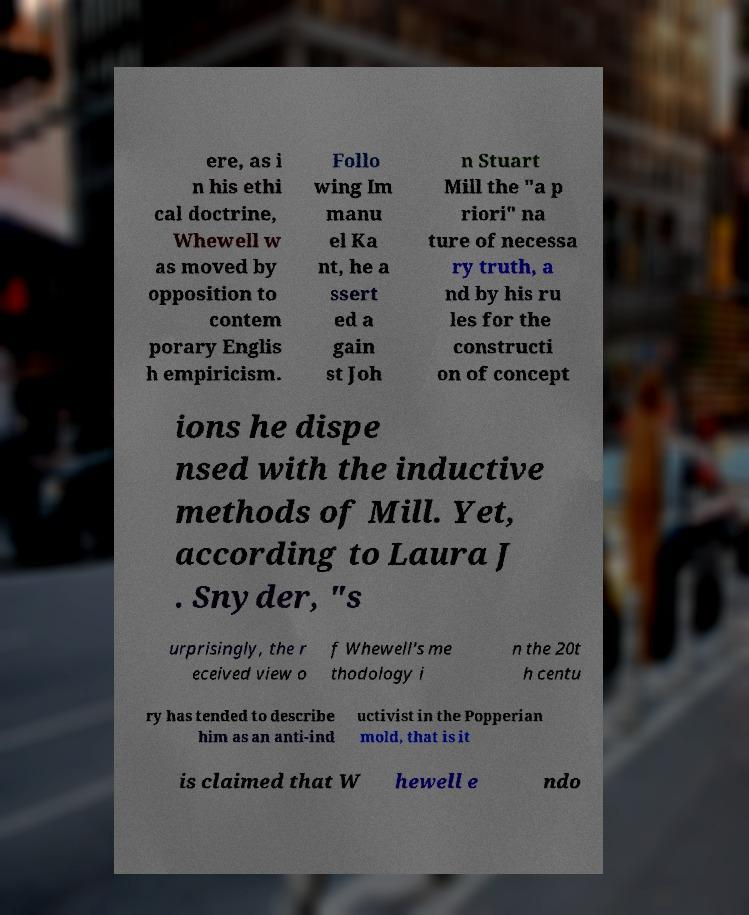For documentation purposes, I need the text within this image transcribed. Could you provide that? ere, as i n his ethi cal doctrine, Whewell w as moved by opposition to contem porary Englis h empiricism. Follo wing Im manu el Ka nt, he a ssert ed a gain st Joh n Stuart Mill the "a p riori" na ture of necessa ry truth, a nd by his ru les for the constructi on of concept ions he dispe nsed with the inductive methods of Mill. Yet, according to Laura J . Snyder, "s urprisingly, the r eceived view o f Whewell's me thodology i n the 20t h centu ry has tended to describe him as an anti-ind uctivist in the Popperian mold, that is it is claimed that W hewell e ndo 